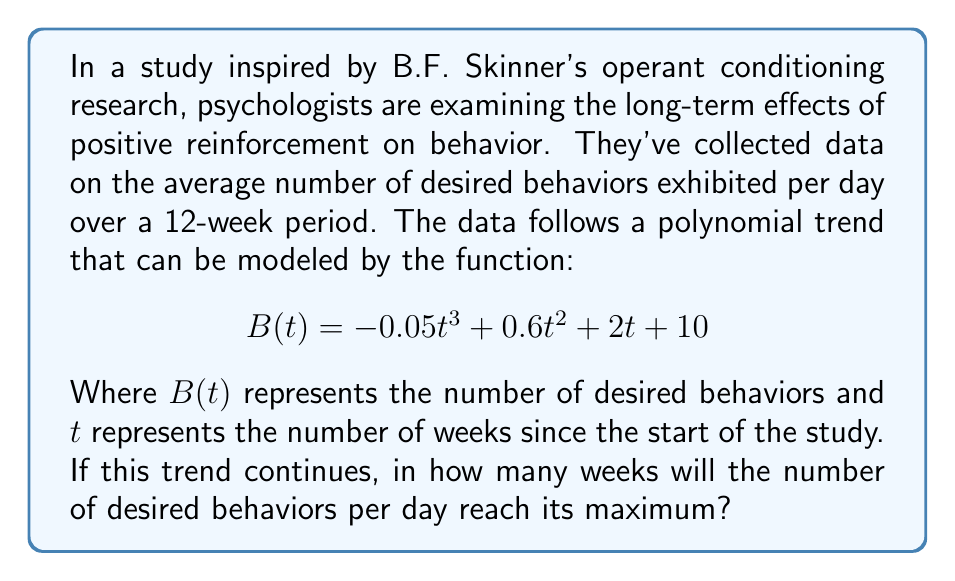What is the answer to this math problem? To solve this problem, we need to find the maximum point of the polynomial function. This can be done by following these steps:

1) First, we need to find the derivative of the function $B(t)$. The derivative will tell us the rate of change of the function:

   $$B'(t) = -0.15t^2 + 1.2t + 2$$

2) To find the maximum point, we need to find where the derivative equals zero:

   $$-0.15t^2 + 1.2t + 2 = 0$$

3) This is a quadratic equation. We can solve it using the quadratic formula:

   $$t = \frac{-b \pm \sqrt{b^2 - 4ac}}{2a}$$

   Where $a = -0.15$, $b = 1.2$, and $c = 2$

4) Plugging in these values:

   $$t = \frac{-1.2 \pm \sqrt{1.44 - 4(-0.15)(2)}}{2(-0.15)}$$

   $$= \frac{-1.2 \pm \sqrt{1.44 + 1.2}}{-0.3}$$

   $$= \frac{-1.2 \pm \sqrt{2.64}}{-0.3}$$

   $$= \frac{-1.2 \pm 1.6248}{-0.3}$$

5) This gives us two solutions:

   $$t_1 = \frac{-1.2 + 1.6248}{-0.3} = -1.4160$$
   $$t_2 = \frac{-1.2 - 1.6248}{-0.3} = 9.4160$$

6) Since time cannot be negative in this context, we discard the negative solution. 

7) We need to confirm this is a maximum, not a minimum. We can do this by checking the second derivative:

   $$B''(t) = -0.3t + 1.2$$

   At $t = 9.4160$, $B''(9.4160) = -1.6248$, which is negative, confirming this is a maximum.

8) Since we're asked for the number of weeks, we need to round 9.4160 to the nearest whole number.
Answer: The number of desired behaviors per day will reach its maximum after approximately 9 weeks. 